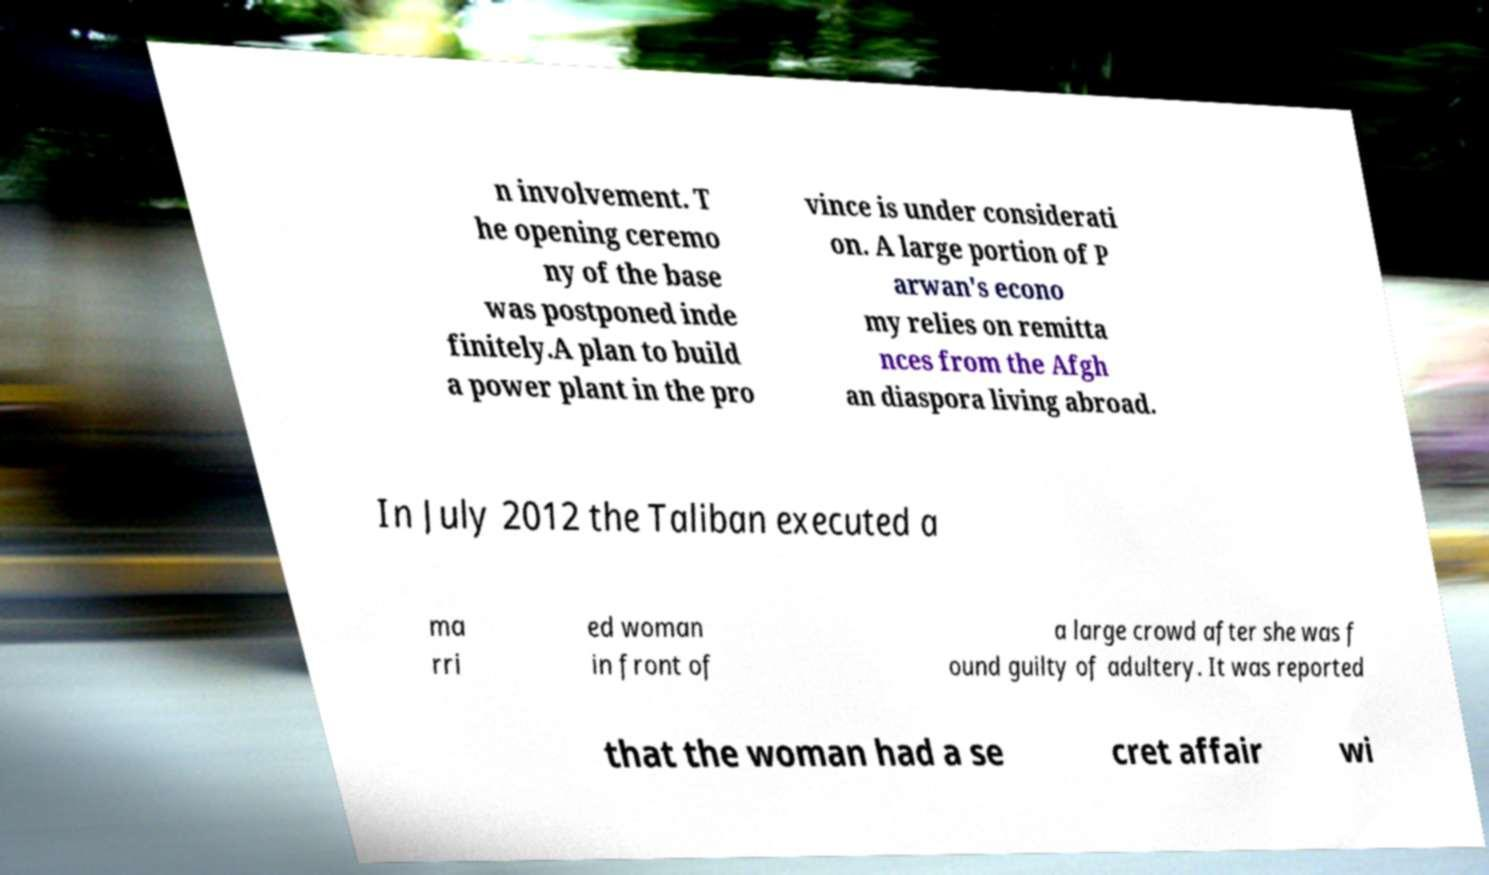Please identify and transcribe the text found in this image. n involvement. T he opening ceremo ny of the base was postponed inde finitely.A plan to build a power plant in the pro vince is under considerati on. A large portion of P arwan's econo my relies on remitta nces from the Afgh an diaspora living abroad. In July 2012 the Taliban executed a ma rri ed woman in front of a large crowd after she was f ound guilty of adultery. It was reported that the woman had a se cret affair wi 